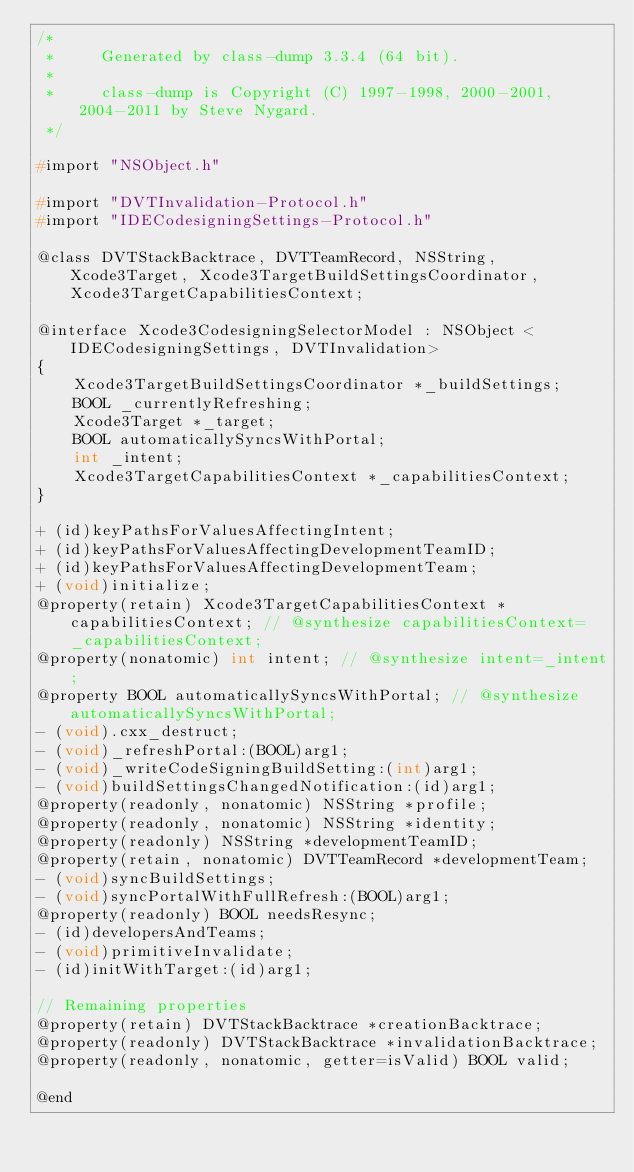<code> <loc_0><loc_0><loc_500><loc_500><_C_>/*
 *     Generated by class-dump 3.3.4 (64 bit).
 *
 *     class-dump is Copyright (C) 1997-1998, 2000-2001, 2004-2011 by Steve Nygard.
 */

#import "NSObject.h"

#import "DVTInvalidation-Protocol.h"
#import "IDECodesigningSettings-Protocol.h"

@class DVTStackBacktrace, DVTTeamRecord, NSString, Xcode3Target, Xcode3TargetBuildSettingsCoordinator, Xcode3TargetCapabilitiesContext;

@interface Xcode3CodesigningSelectorModel : NSObject <IDECodesigningSettings, DVTInvalidation>
{
    Xcode3TargetBuildSettingsCoordinator *_buildSettings;
    BOOL _currentlyRefreshing;
    Xcode3Target *_target;
    BOOL automaticallySyncsWithPortal;
    int _intent;
    Xcode3TargetCapabilitiesContext *_capabilitiesContext;
}

+ (id)keyPathsForValuesAffectingIntent;
+ (id)keyPathsForValuesAffectingDevelopmentTeamID;
+ (id)keyPathsForValuesAffectingDevelopmentTeam;
+ (void)initialize;
@property(retain) Xcode3TargetCapabilitiesContext *capabilitiesContext; // @synthesize capabilitiesContext=_capabilitiesContext;
@property(nonatomic) int intent; // @synthesize intent=_intent;
@property BOOL automaticallySyncsWithPortal; // @synthesize automaticallySyncsWithPortal;
- (void).cxx_destruct;
- (void)_refreshPortal:(BOOL)arg1;
- (void)_writeCodeSigningBuildSetting:(int)arg1;
- (void)buildSettingsChangedNotification:(id)arg1;
@property(readonly, nonatomic) NSString *profile;
@property(readonly, nonatomic) NSString *identity;
@property(readonly) NSString *developmentTeamID;
@property(retain, nonatomic) DVTTeamRecord *developmentTeam;
- (void)syncBuildSettings;
- (void)syncPortalWithFullRefresh:(BOOL)arg1;
@property(readonly) BOOL needsResync;
- (id)developersAndTeams;
- (void)primitiveInvalidate;
- (id)initWithTarget:(id)arg1;

// Remaining properties
@property(retain) DVTStackBacktrace *creationBacktrace;
@property(readonly) DVTStackBacktrace *invalidationBacktrace;
@property(readonly, nonatomic, getter=isValid) BOOL valid;

@end

</code> 